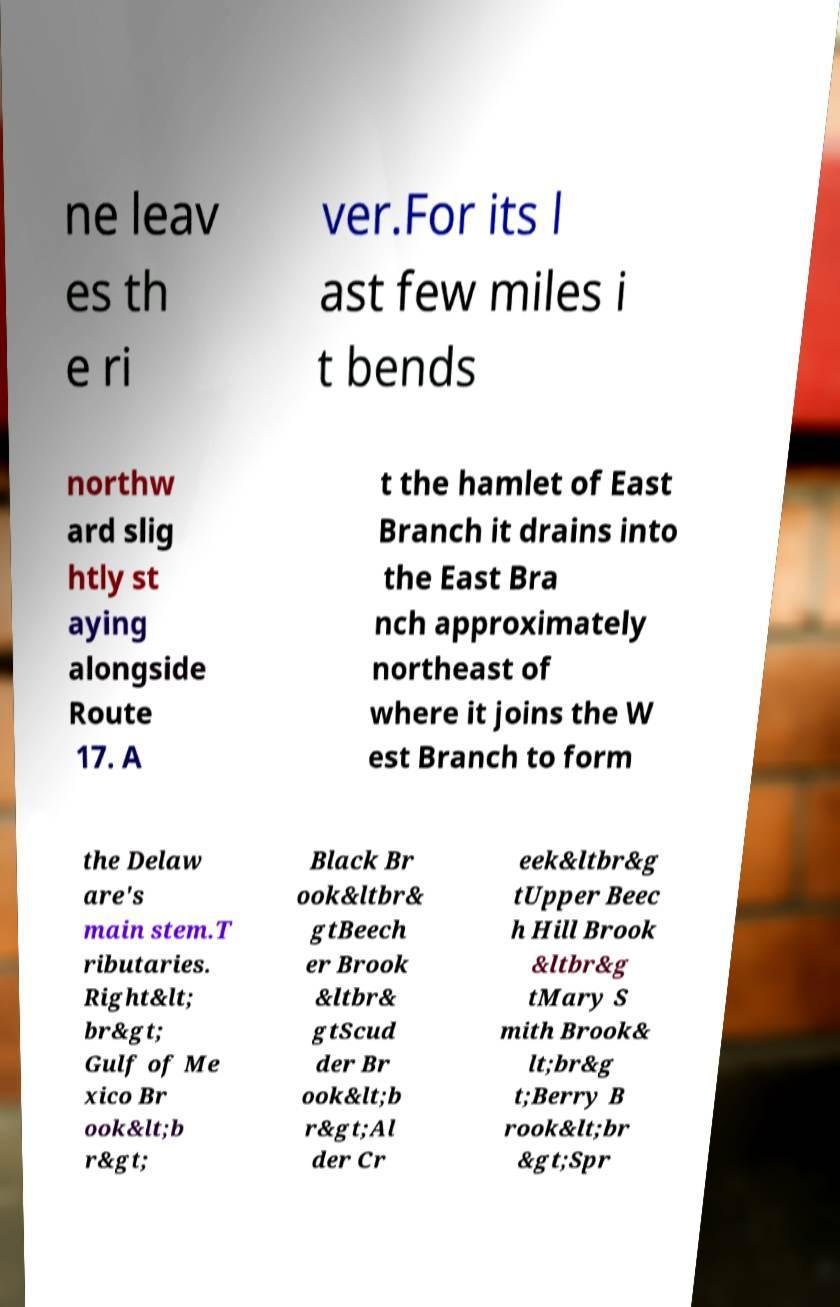Could you extract and type out the text from this image? ne leav es th e ri ver.For its l ast few miles i t bends northw ard slig htly st aying alongside Route 17. A t the hamlet of East Branch it drains into the East Bra nch approximately northeast of where it joins the W est Branch to form the Delaw are's main stem.T ributaries. Right&lt; br&gt; Gulf of Me xico Br ook&lt;b r&gt; Black Br ook&ltbr& gtBeech er Brook &ltbr& gtScud der Br ook&lt;b r&gt;Al der Cr eek&ltbr&g tUpper Beec h Hill Brook &ltbr&g tMary S mith Brook& lt;br&g t;Berry B rook&lt;br &gt;Spr 